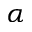Convert formula to latex. <formula><loc_0><loc_0><loc_500><loc_500>\alpha</formula> 